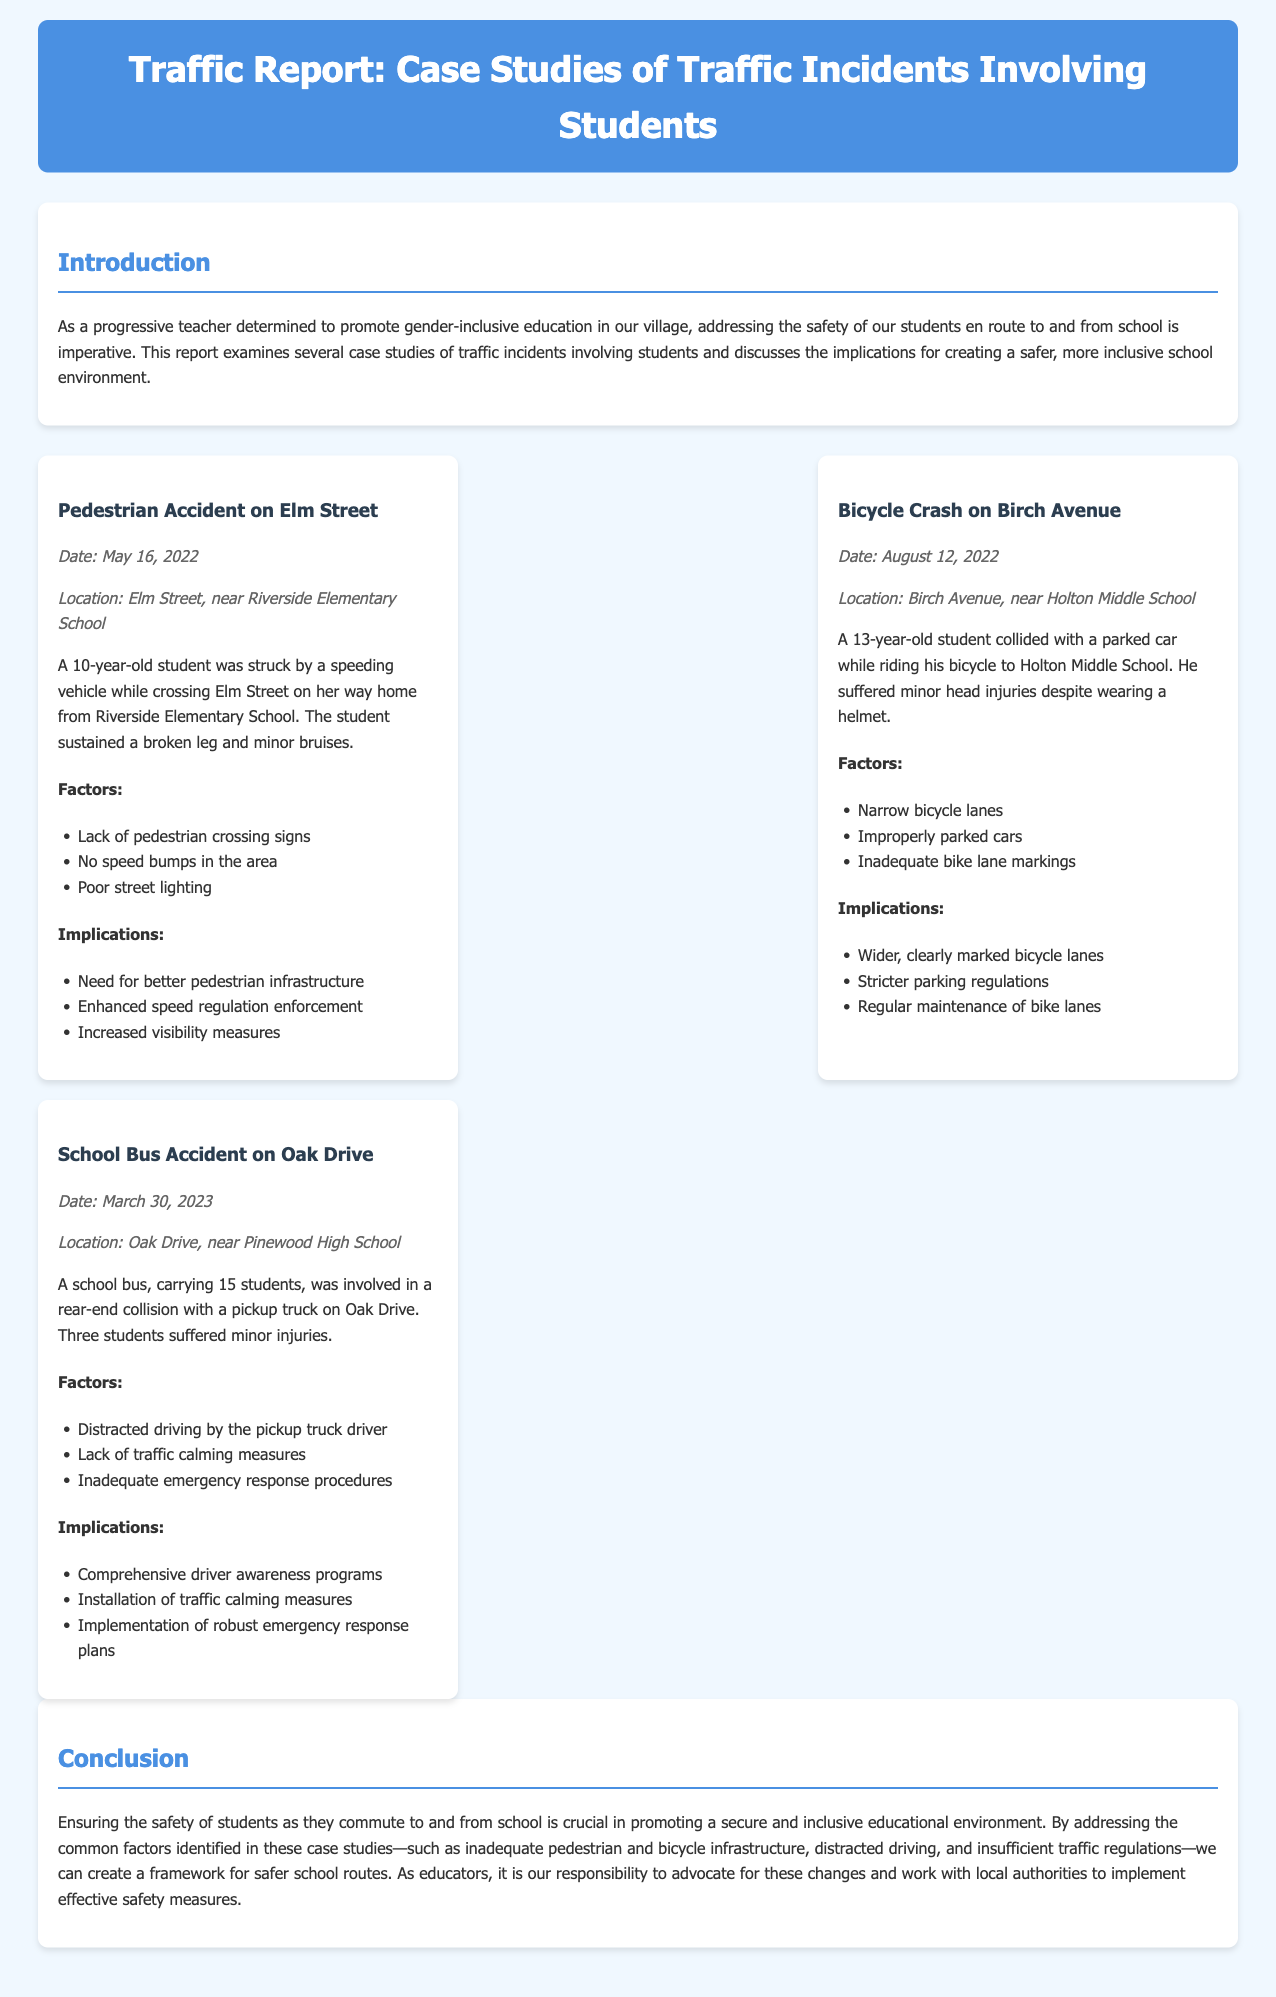What is the date of the pedestrian accident? The pedestrian accident occurred on May 16, 2022, as stated in the case study.
Answer: May 16, 2022 What injury did the 10-year-old student sustain? The document states that the student sustained a broken leg and minor bruises in the pedestrian accident.
Answer: Broken leg Which school was involved in the bicycle crash case? The bicycle crash case occurred near Holton Middle School, as mentioned in the document.
Answer: Holton Middle School How many students were injured in the school bus accident? The report specifies that three students suffered minor injuries in the school bus accident.
Answer: Three students What is one factor mentioned in the pedestrian accident case? The case study lists several factors leading to the pedestrian accident; one of them is the lack of pedestrian crossing signs.
Answer: Lack of pedestrian crossing signs What does the report suggest is needed after the bicycle crash incident? The document highlights the need for wider, clearly marked bicycle lanes following the bicycle crash.
Answer: Wider, clearly marked bicycle lanes What is the purpose of this traffic report? The report aims to discuss traffic incidents involving students and their implications for a safer school environment.
Answer: Safer school environment What was the primary cause of the school bus accident? The report identifies distracted driving by the pickup truck driver as a primary cause of the school bus accident.
Answer: Distracted driving What should be implemented for better traffic safety according to the report? The report suggests implementing comprehensive driver awareness programs for better traffic safety.
Answer: Comprehensive driver awareness programs 